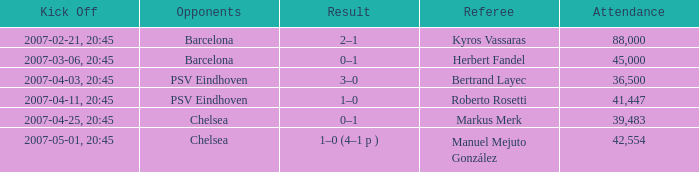Which competitor initiated a match on 2007-03-06, 20:45? Barcelona. 